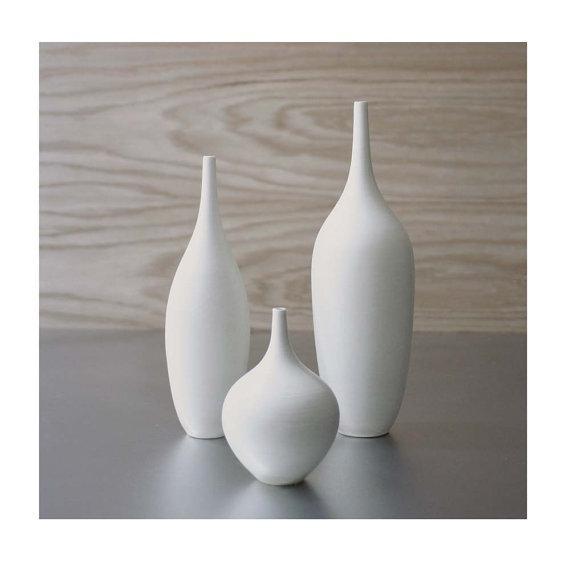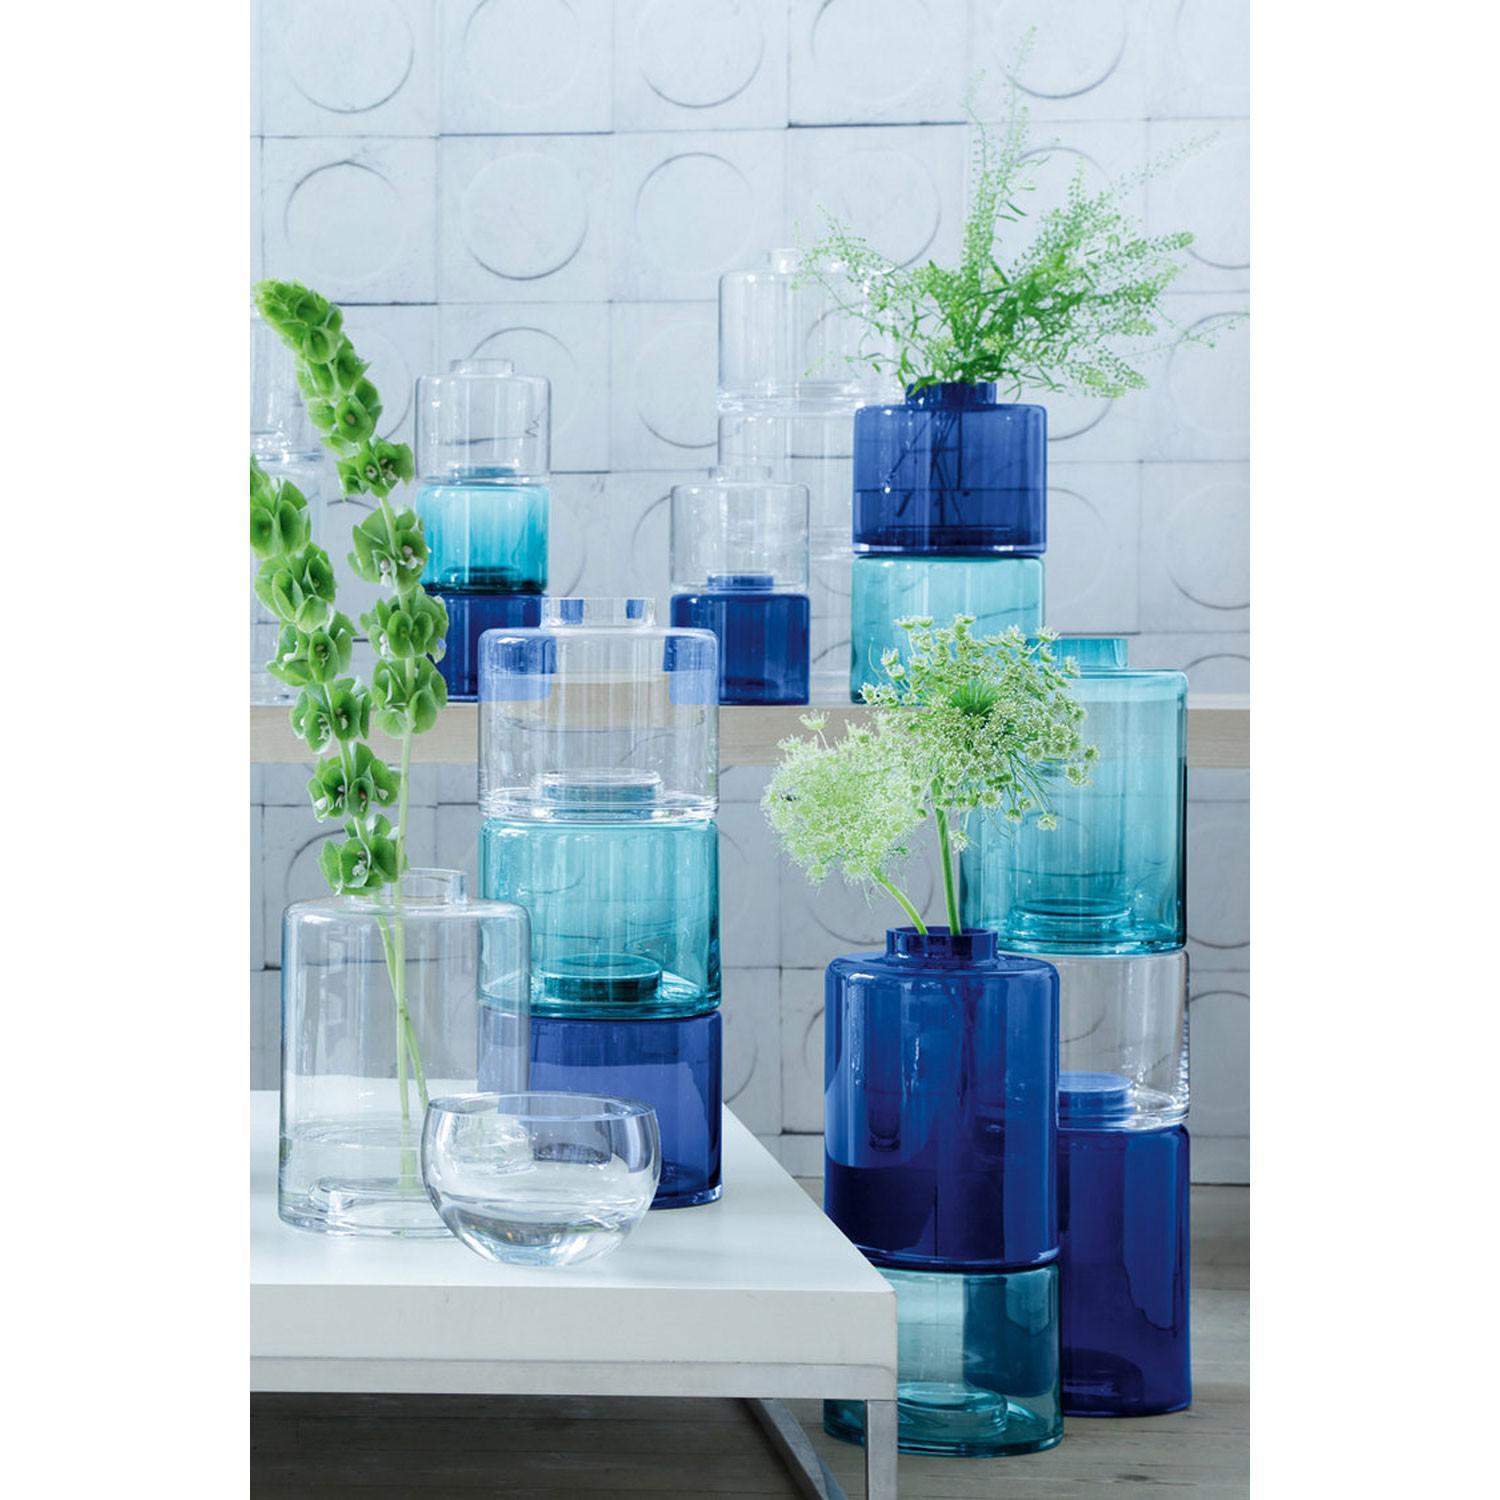The first image is the image on the left, the second image is the image on the right. For the images shown, is this caption "One photo shows at least three exclusively white opaque decorative containers that are not holding flowers." true? Answer yes or no. Yes. The first image is the image on the left, the second image is the image on the right. Given the left and right images, does the statement "Both images contain flowering plants in vertical containers." hold true? Answer yes or no. No. 